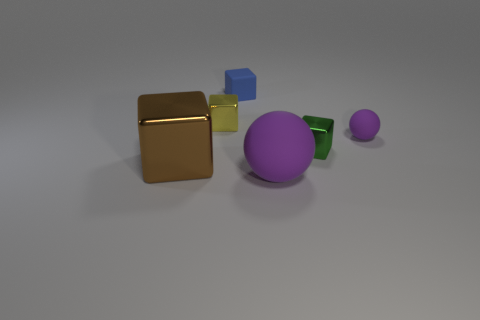Subtract all small blue matte cubes. How many cubes are left? 3 Add 4 green metallic things. How many objects exist? 10 Subtract 1 blocks. How many blocks are left? 3 Subtract all spheres. How many objects are left? 4 Subtract all green blocks. How many blocks are left? 3 Subtract 0 cyan cylinders. How many objects are left? 6 Subtract all blue blocks. Subtract all red cylinders. How many blocks are left? 3 Subtract all large yellow rubber objects. Subtract all small matte balls. How many objects are left? 5 Add 3 large purple matte balls. How many large purple matte balls are left? 4 Add 3 purple things. How many purple things exist? 5 